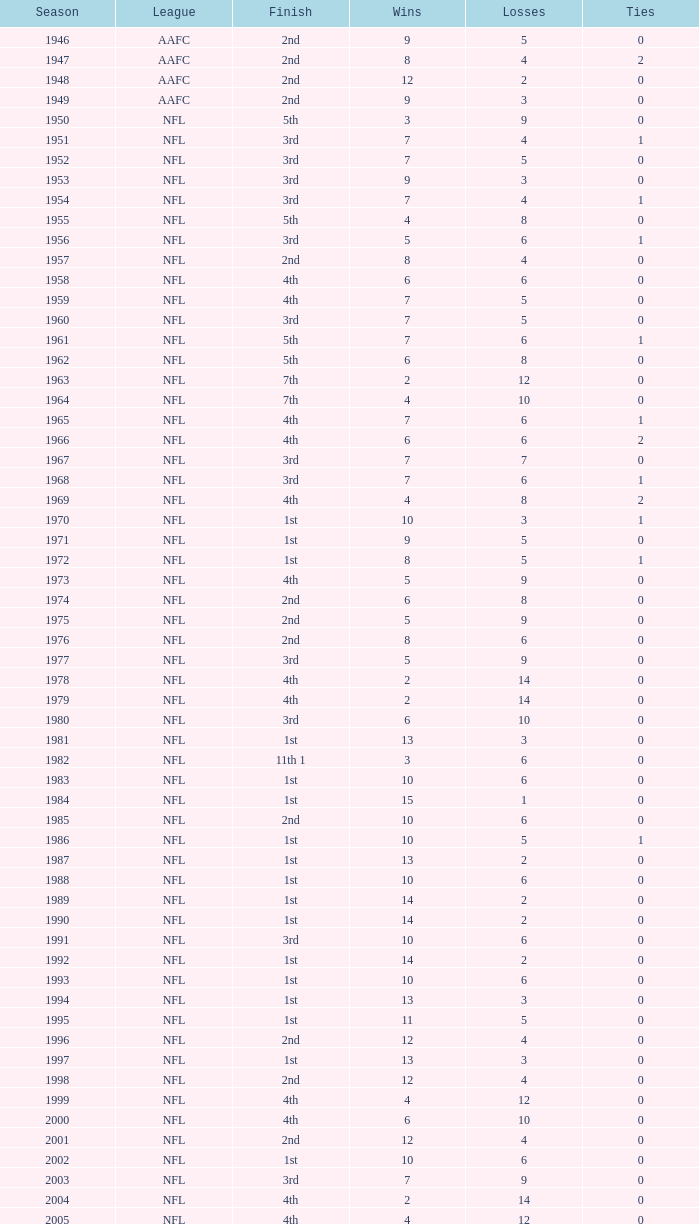How many losses occur when the ties are less than 0? 0.0. 